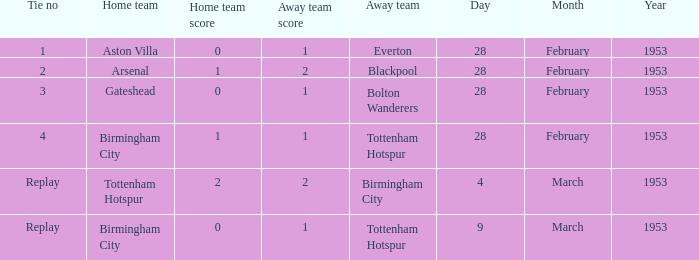Can you give me this table as a dict? {'header': ['Tie no', 'Home team', 'Home team score', 'Away team score', 'Away team', 'Day', 'Month', 'Year'], 'rows': [['1', 'Aston Villa', '0', '1', 'Everton', '28', 'February', '1953'], ['2', 'Arsenal', '1', '2', 'Blackpool', '28', 'February', '1953'], ['3', 'Gateshead', '0', '1', 'Bolton Wanderers', '28', 'February', '1953'], ['4', 'Birmingham City', '1', '1', 'Tottenham Hotspur', '28', 'February', '1953'], ['Replay', 'Tottenham Hotspur', '2', '2', 'Birmingham City', '4', 'March', '1953'], ['Replay', 'Birmingham City', '0', '1', 'Tottenham Hotspur', '9', 'March', '1953']]} Which tie no possesses a score of 0–1, and a date of 9 march 1953? Replay. 